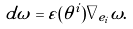Convert formula to latex. <formula><loc_0><loc_0><loc_500><loc_500>d \omega = \varepsilon ( \theta ^ { i } ) \nabla _ { e _ { i } } \omega .</formula> 